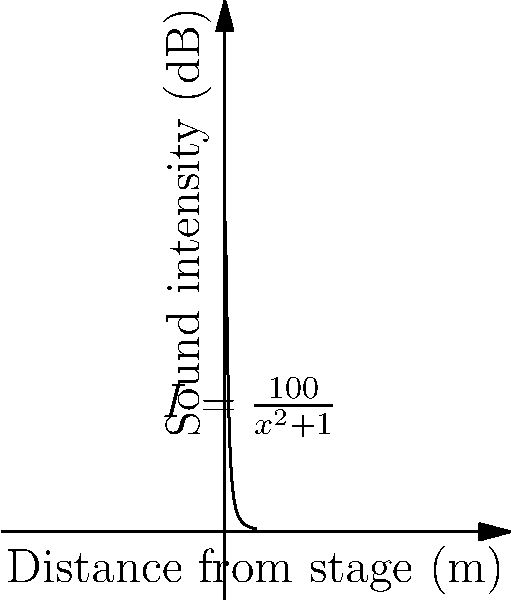At a heavy metal concert, the sound intensity $I$ (in decibels) at a distance $x$ (in meters) from the stage is modeled by the function $I(x) = \frac{100}{x^2+1}$. Find the rate of change of sound intensity with respect to distance when a fan is standing 3 meters from the stage. To find the rate of change of sound intensity with respect to distance, we need to differentiate $I(x)$ with respect to $x$ and then evaluate it at $x=3$.

Step 1: Differentiate $I(x) = \frac{100}{x^2+1}$
Using the quotient rule, we get:
$$I'(x) = \frac{-200x}{(x^2+1)^2}$$

Step 2: Evaluate $I'(x)$ at $x=3$
$$I'(3) = \frac{-200(3)}{(3^2+1)^2} = \frac{-600}{100} = -6$$

Therefore, when a fan is standing 3 meters from the stage, the rate of change of sound intensity with respect to distance is -6 dB/m.
Answer: $-6$ dB/m 